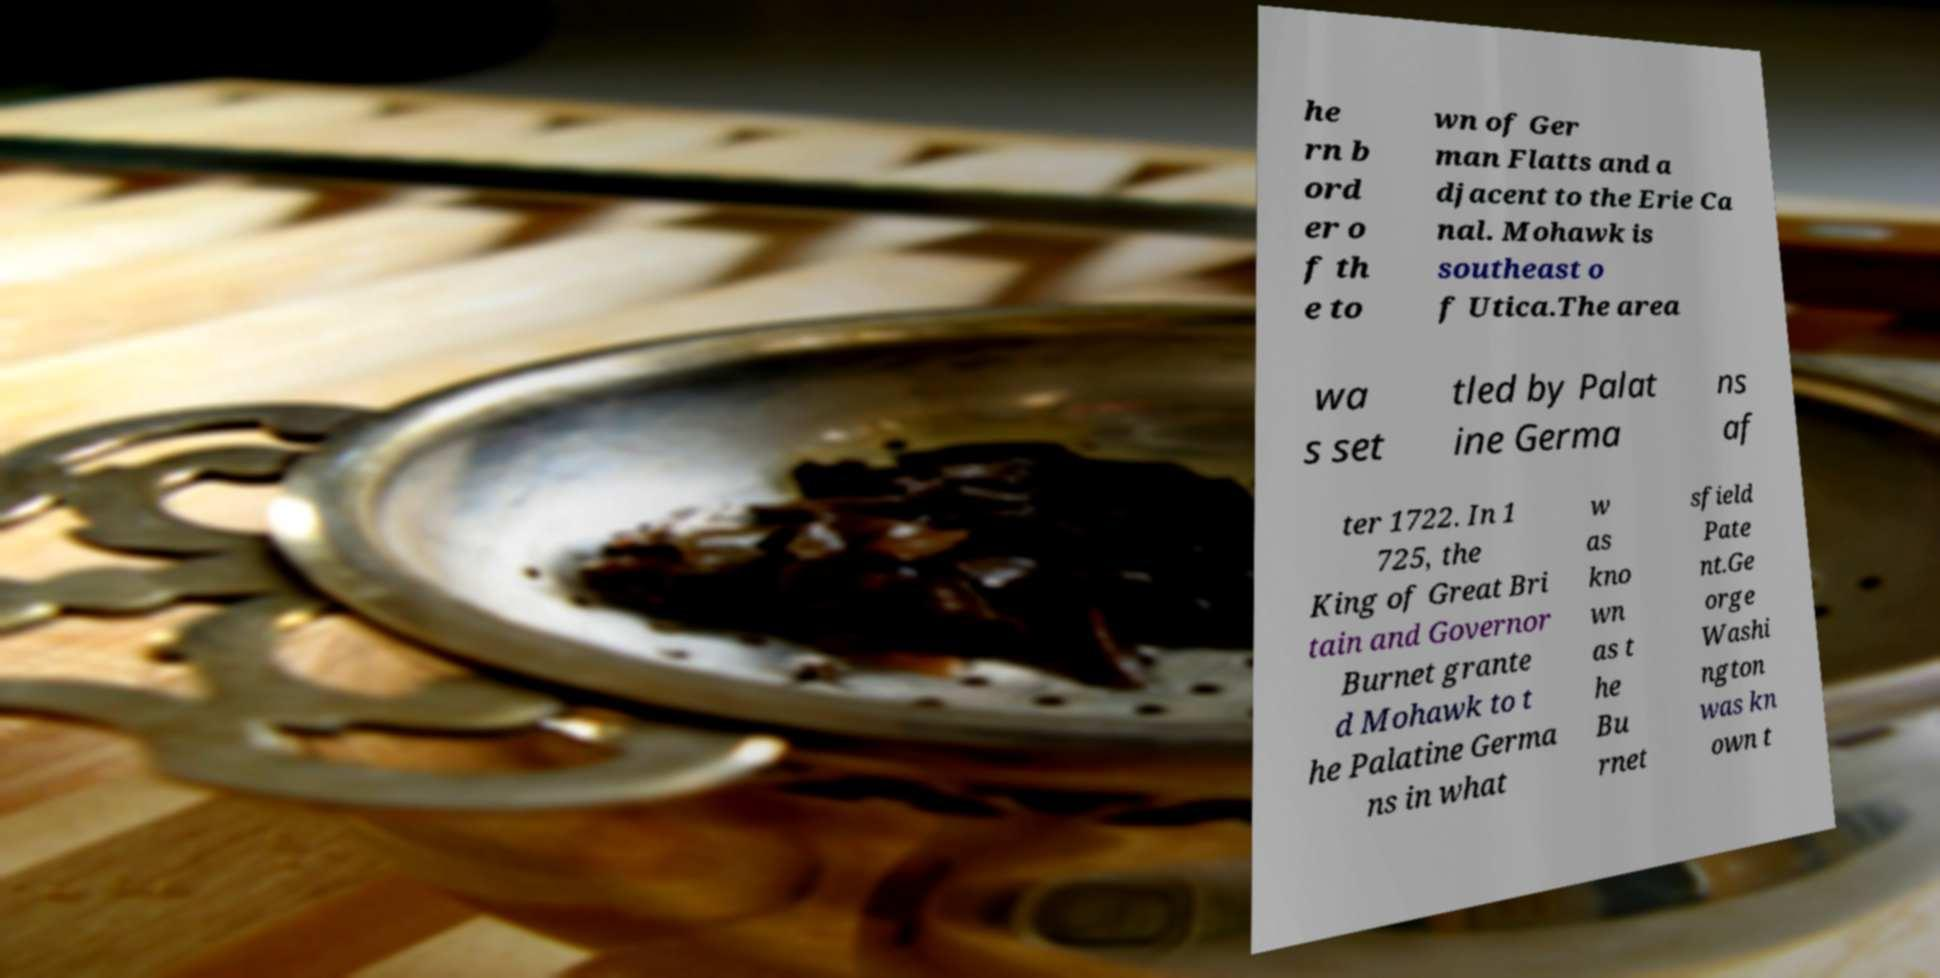For documentation purposes, I need the text within this image transcribed. Could you provide that? he rn b ord er o f th e to wn of Ger man Flatts and a djacent to the Erie Ca nal. Mohawk is southeast o f Utica.The area wa s set tled by Palat ine Germa ns af ter 1722. In 1 725, the King of Great Bri tain and Governor Burnet grante d Mohawk to t he Palatine Germa ns in what w as kno wn as t he Bu rnet sfield Pate nt.Ge orge Washi ngton was kn own t 